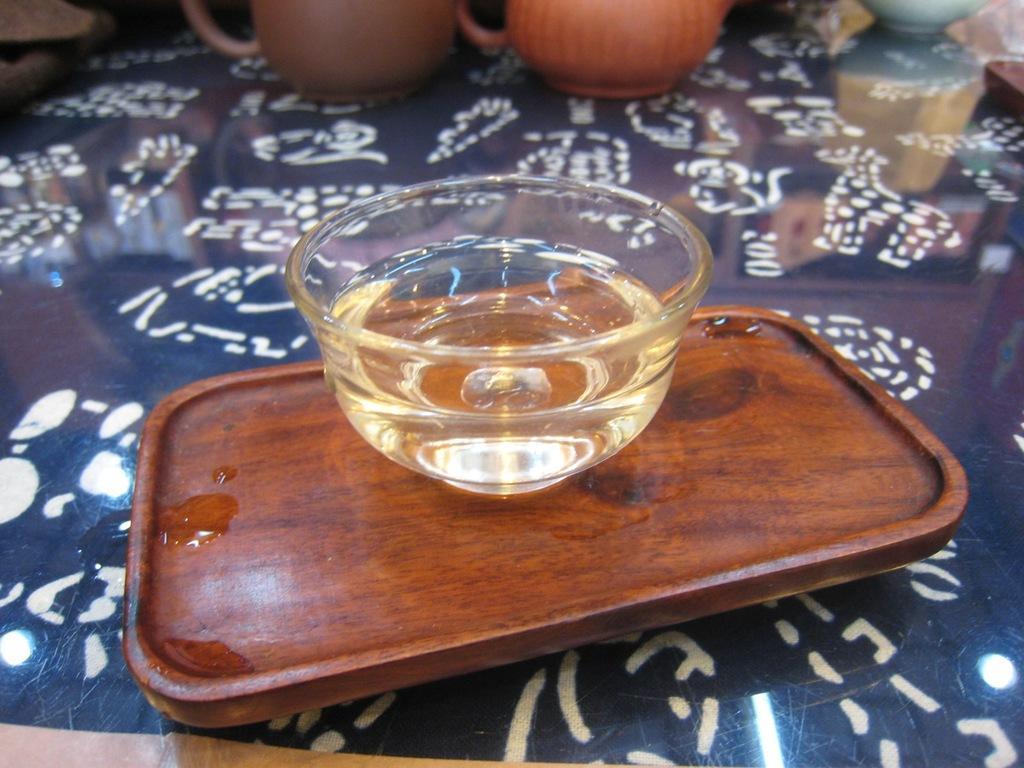In one or two sentences, can you explain what this image depicts? At the bottom of this image, there is an oil in a glass cup which is on a wooden plate. This plate is on a table, on which there are two cups and other objects. 